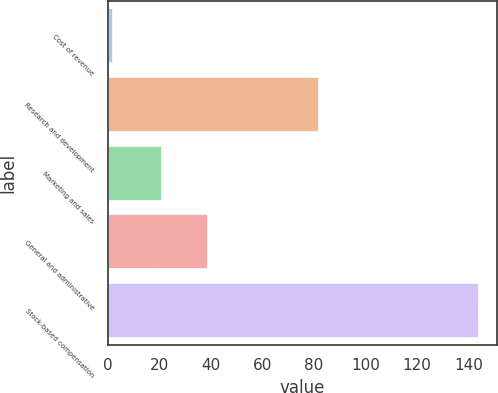Convert chart. <chart><loc_0><loc_0><loc_500><loc_500><bar_chart><fcel>Cost of revenue<fcel>Research and development<fcel>Marketing and sales<fcel>General and administrative<fcel>Stock-based compensation<nl><fcel>2<fcel>82<fcel>21<fcel>39<fcel>144<nl></chart> 